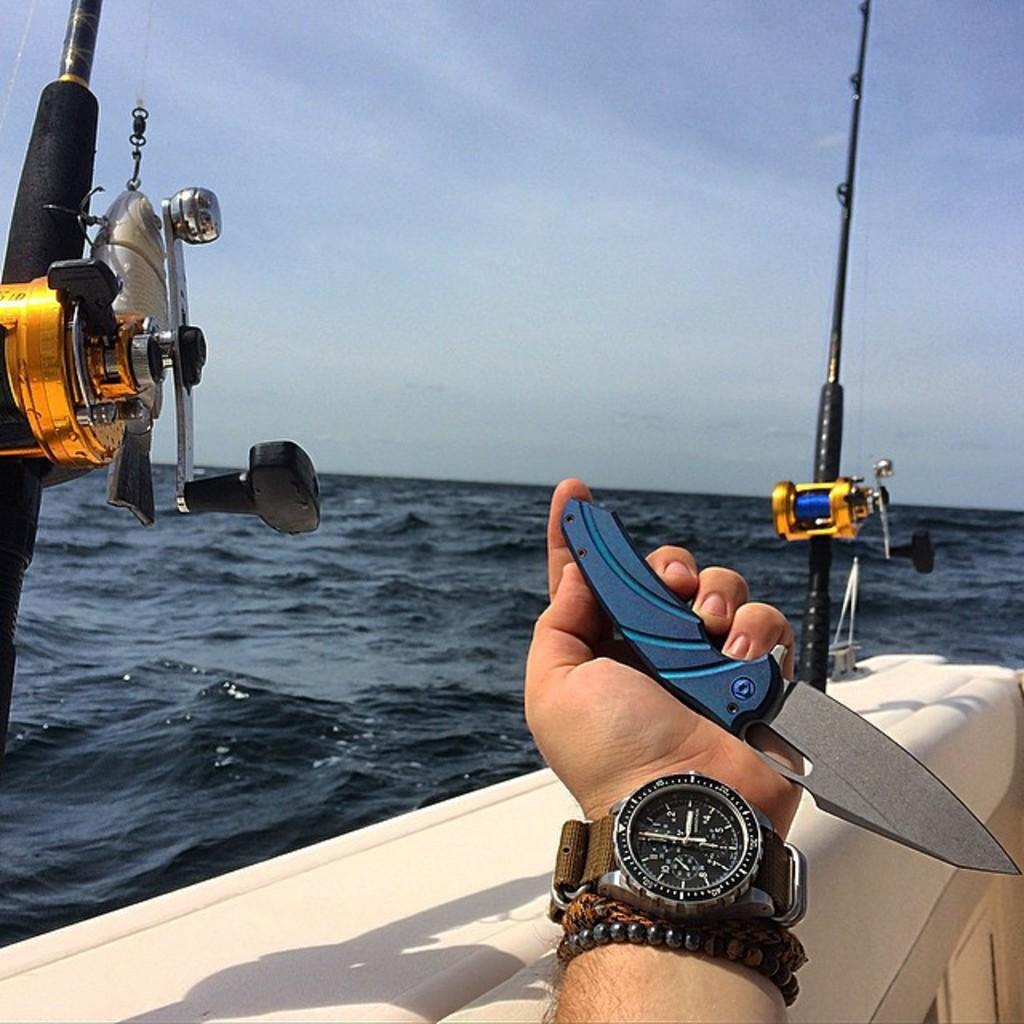<image>
Create a compact narrative representing the image presented. Man's arm is visible holding a fishing knife and has a watch on showing number 2. 